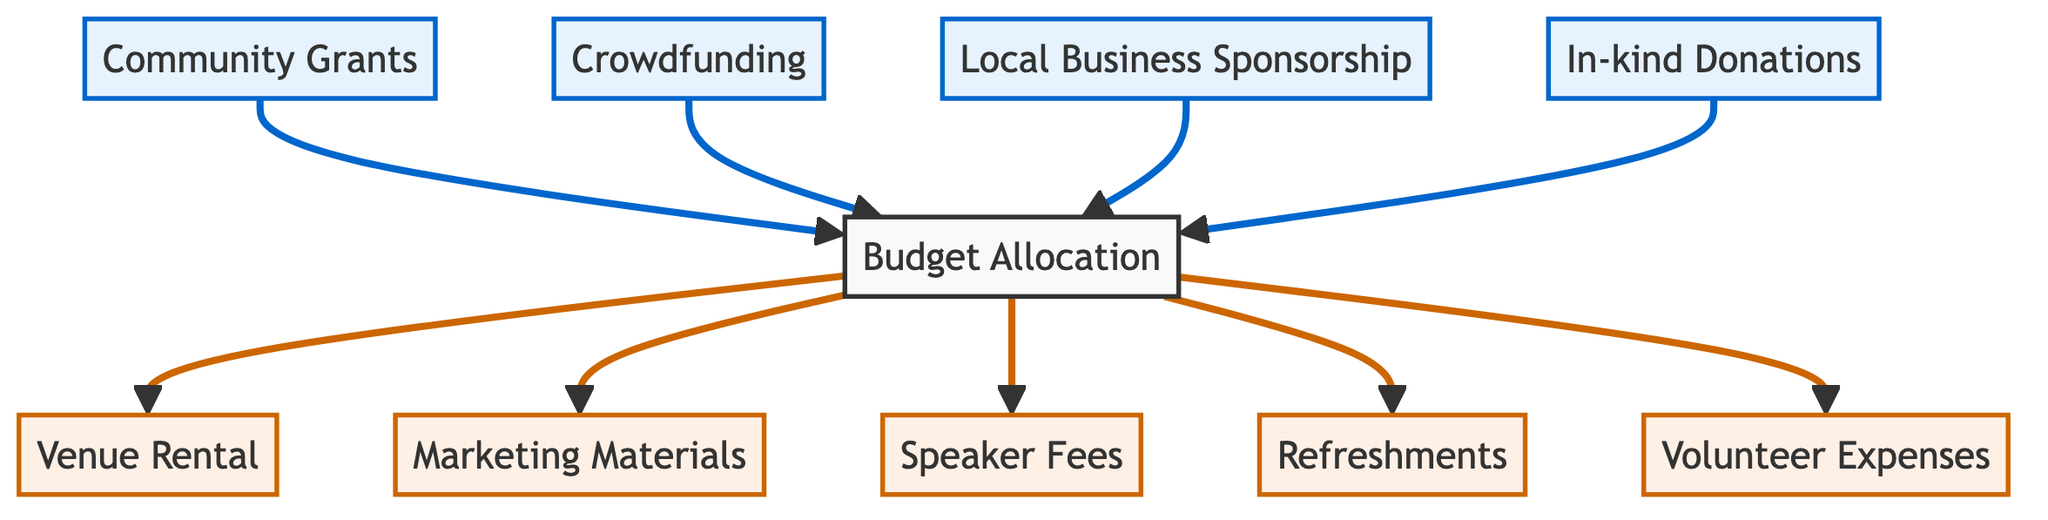What are the funding sources for the budget allocation? The diagram shows that the funding sources feeding into "Budget Allocation" include "Community Grants," "Crowdfunding," "Local Business Sponsorship," and "In-kind Donations."
Answer: Community Grants, Crowdfunding, Local Business Sponsorship, In-kind Donations How many expense categories are shown in the diagram? The diagram lists a total of five expense categories linked to "Budget Allocation": "Venue Rental," "Marketing Materials," "Speaker Fees," "Refreshments," and "Volunteer Expenses."
Answer: Five Which category is directly connected to Speaker Fees? "Speaker Fees" is directly connected to "Budget Allocation," indicating that it is one of the expenses funded by the overall budget.
Answer: Budget Allocation Which funding source is explicitly shown as the only one leading to the budget allocation? The question suggests looking for a singular funding source, but the diagram indicates that multiple funding sources connect to the "Budget Allocation," thus it does not provide a single flow.
Answer: None (multiple sources) How many edges connect to the Venue Rental? "Venue Rental" has a single edge connecting it to "Budget Allocation," which signifies that funding for it comes solely from the budget.
Answer: One Which is the main node in the diagram? The main node from which all expenses are derived is "Budget Allocation," as all expense categories connect back to it.
Answer: Budget Allocation What is the relationship between Crowdfunding and Budget Allocation? "Crowdfunding" directly points to "Budget Allocation," meaning it serves as one of the funding sources for the budget.
Answer: Funding source What types of elements are represented as funding in the diagram? The diagram classifies "Community Grants," "Crowdfunding," "Local Business Sponsorship," and "In-kind Donations" as funding elements, highlighted differently from expenses.
Answer: Funding sources Identify the type of elements represented by Volunteer Expenses. "Volunteer Expenses" is categorized as an expense, representing costs associated with the campaign implementation from the budget allocation.
Answer: Expense 